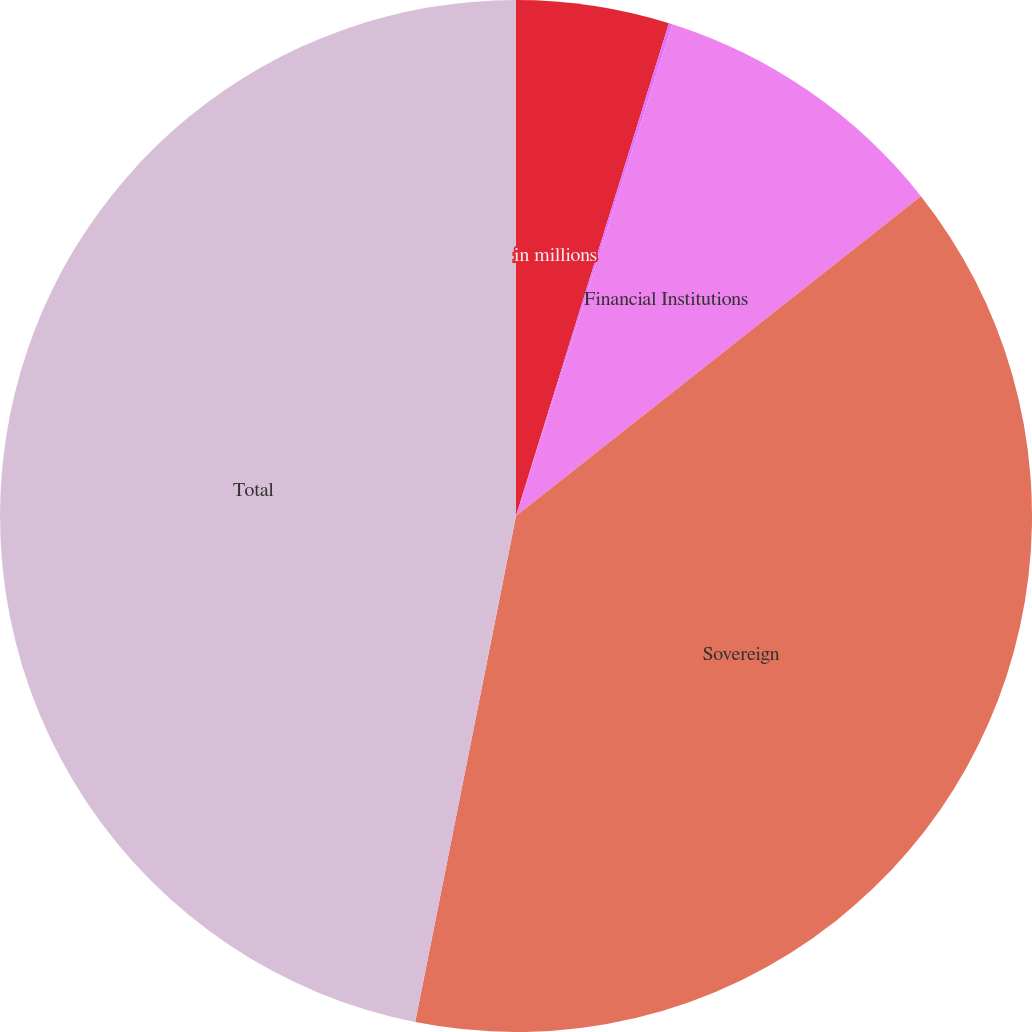<chart> <loc_0><loc_0><loc_500><loc_500><pie_chart><fcel>in millions<fcel>Funds<fcel>Financial Institutions<fcel>Sovereign<fcel>Total<nl><fcel>4.79%<fcel>0.11%<fcel>9.46%<fcel>38.77%<fcel>46.87%<nl></chart> 